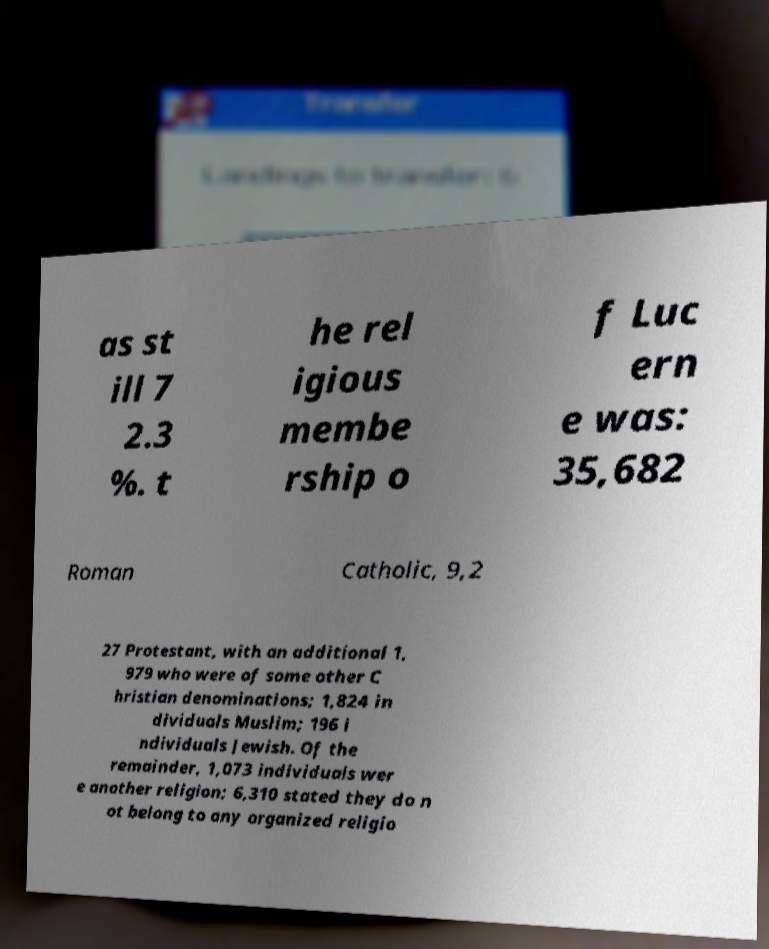I need the written content from this picture converted into text. Can you do that? as st ill 7 2.3 %. t he rel igious membe rship o f Luc ern e was: 35,682 Roman Catholic, 9,2 27 Protestant, with an additional 1, 979 who were of some other C hristian denominations; 1,824 in dividuals Muslim; 196 i ndividuals Jewish. Of the remainder, 1,073 individuals wer e another religion; 6,310 stated they do n ot belong to any organized religio 